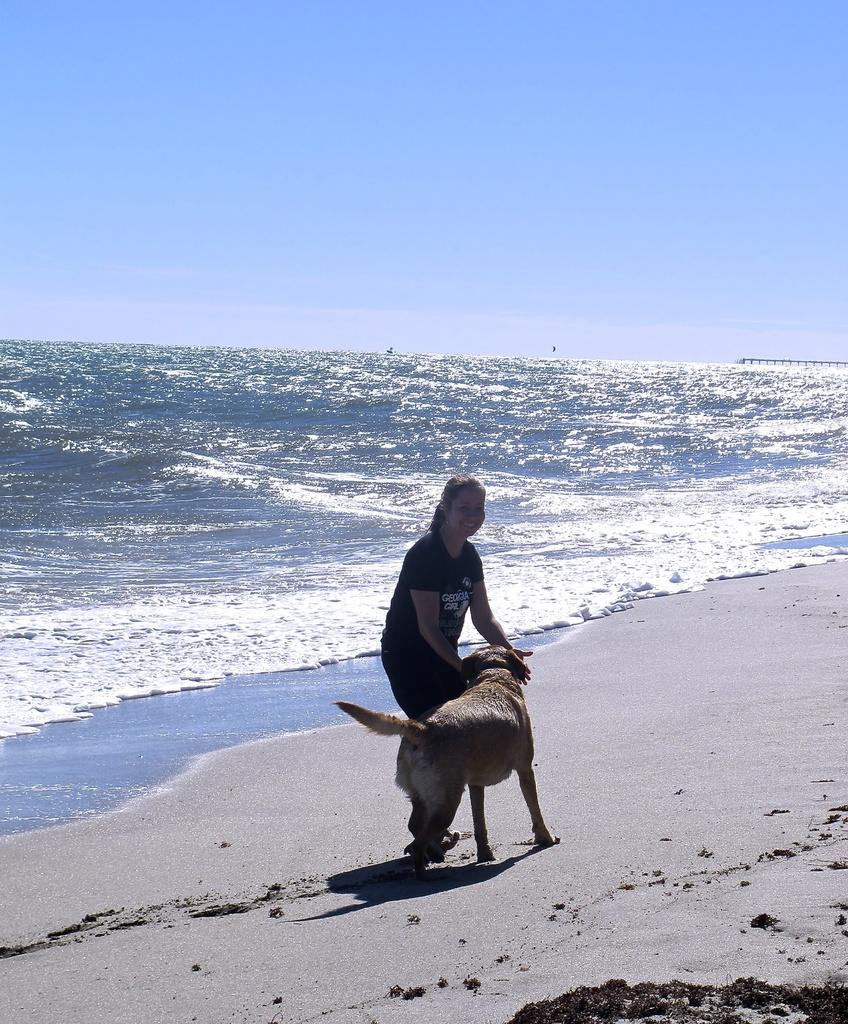What type of animal is in the image? There is a dog in the image. Who else is present in the image? There is a woman in the image. Where are the dog and the woman located? Both the dog and the woman are standing on the seashore. What natural features can be seen in the image? The sea and the sky are visible in the image. What is the condition of the sky in the image? Clouds are present in the sky. What type of sack is the dog carrying on the seashore? There is no sack present in the image; the dog is not carrying anything. How many rays are visible in the image? There are no rays visible in the image; it features a dog, a woman, and a seashore setting. 